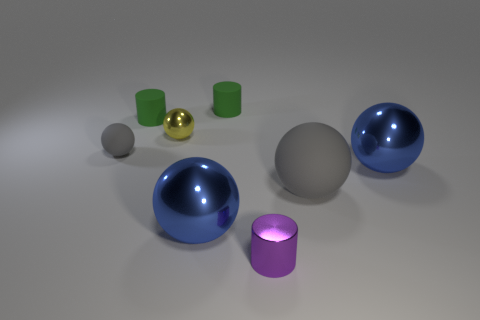What is the gray thing that is behind the gray ball that is in front of the tiny gray sphere made of?
Your answer should be very brief. Rubber. Does the tiny gray object have the same shape as the large blue metallic object that is on the right side of the small purple object?
Provide a succinct answer. Yes. What number of matte objects are cylinders or tiny gray balls?
Your answer should be compact. 3. There is a small ball that is in front of the yellow sphere to the right of the green cylinder that is to the left of the tiny yellow metallic sphere; what is its color?
Keep it short and to the point. Gray. How many other objects are the same material as the yellow thing?
Your response must be concise. 3. There is a tiny rubber object in front of the small yellow object; is its shape the same as the large gray object?
Offer a very short reply. Yes. How many small objects are rubber objects or purple matte objects?
Your answer should be very brief. 3. Is the number of gray rubber balls to the right of the tiny gray rubber ball the same as the number of small gray matte things to the right of the yellow sphere?
Your answer should be very brief. No. What number of other things are there of the same color as the large rubber ball?
Provide a succinct answer. 1. Do the big rubber object and the matte ball on the left side of the tiny purple shiny cylinder have the same color?
Offer a very short reply. Yes. 